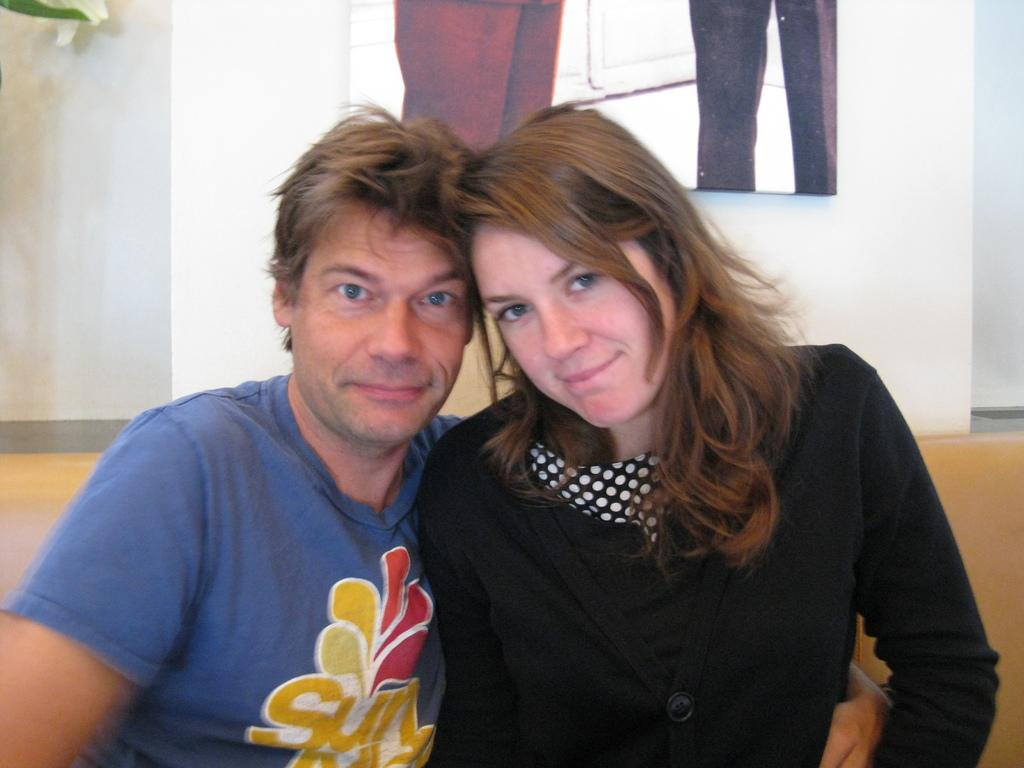How many people are present in the image? There are two people in the image. What can be seen in the background of the image? There is a wall in the background of the image. What type of cracker is the frog eating inside the tent in the image? There is no tent, frog, or cracker present in the image. 